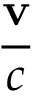Convert formula to latex. <formula><loc_0><loc_0><loc_500><loc_500>\frac { v } { c }</formula> 